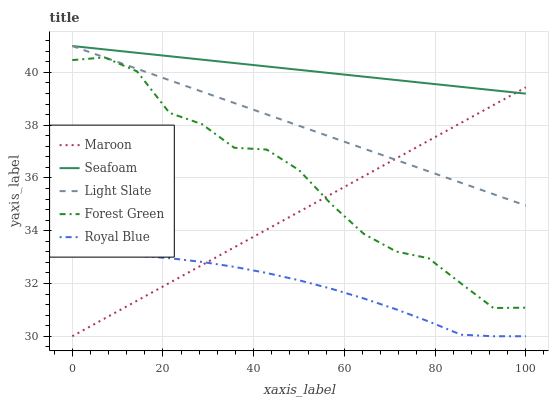Does Royal Blue have the minimum area under the curve?
Answer yes or no. Yes. Does Seafoam have the maximum area under the curve?
Answer yes or no. Yes. Does Forest Green have the minimum area under the curve?
Answer yes or no. No. Does Forest Green have the maximum area under the curve?
Answer yes or no. No. Is Seafoam the smoothest?
Answer yes or no. Yes. Is Forest Green the roughest?
Answer yes or no. Yes. Is Royal Blue the smoothest?
Answer yes or no. No. Is Royal Blue the roughest?
Answer yes or no. No. Does Forest Green have the lowest value?
Answer yes or no. No. Does Seafoam have the highest value?
Answer yes or no. Yes. Does Forest Green have the highest value?
Answer yes or no. No. Is Royal Blue less than Forest Green?
Answer yes or no. Yes. Is Forest Green greater than Royal Blue?
Answer yes or no. Yes. Does Royal Blue intersect Forest Green?
Answer yes or no. No. 